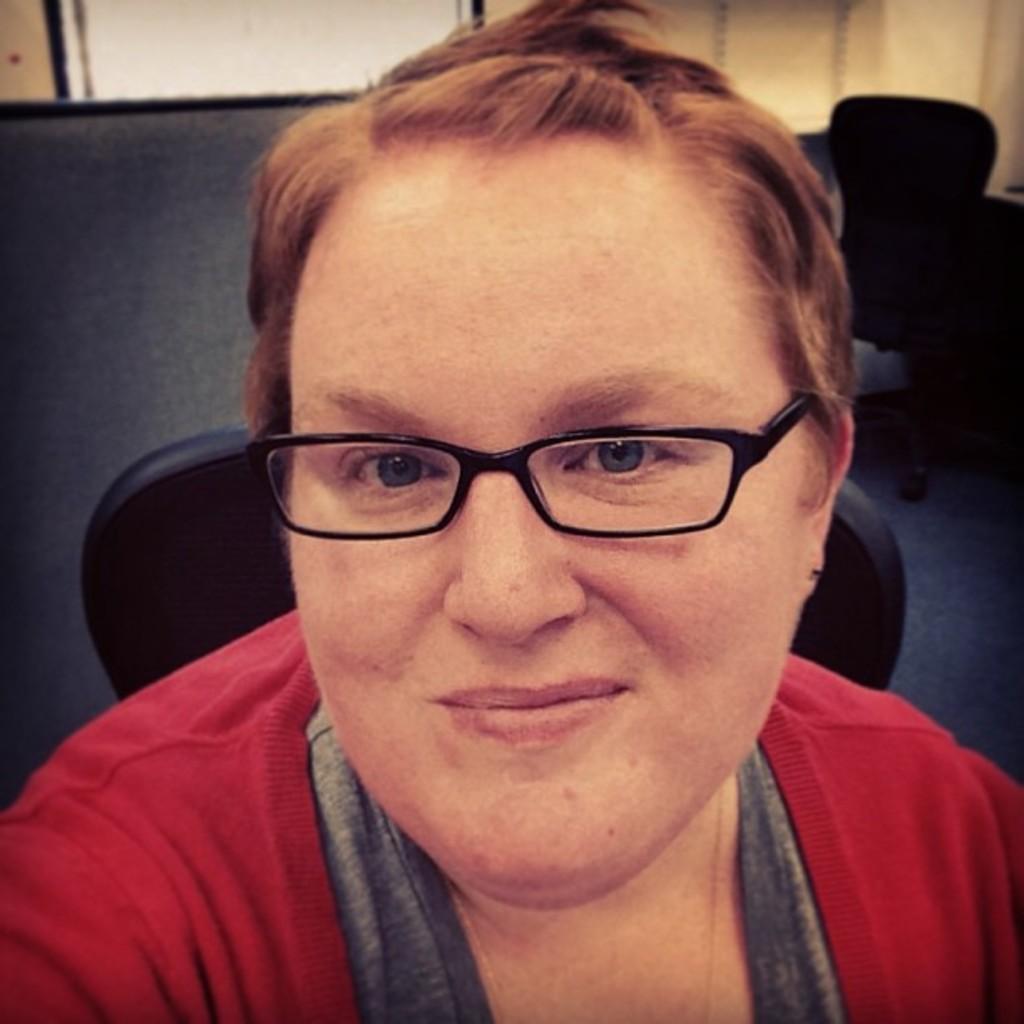In one or two sentences, can you explain what this image depicts? In this image we can see a lady is sitting on the chair. There is a chair behind a person. 